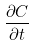Convert formula to latex. <formula><loc_0><loc_0><loc_500><loc_500>\frac { \partial C } { \partial t }</formula> 